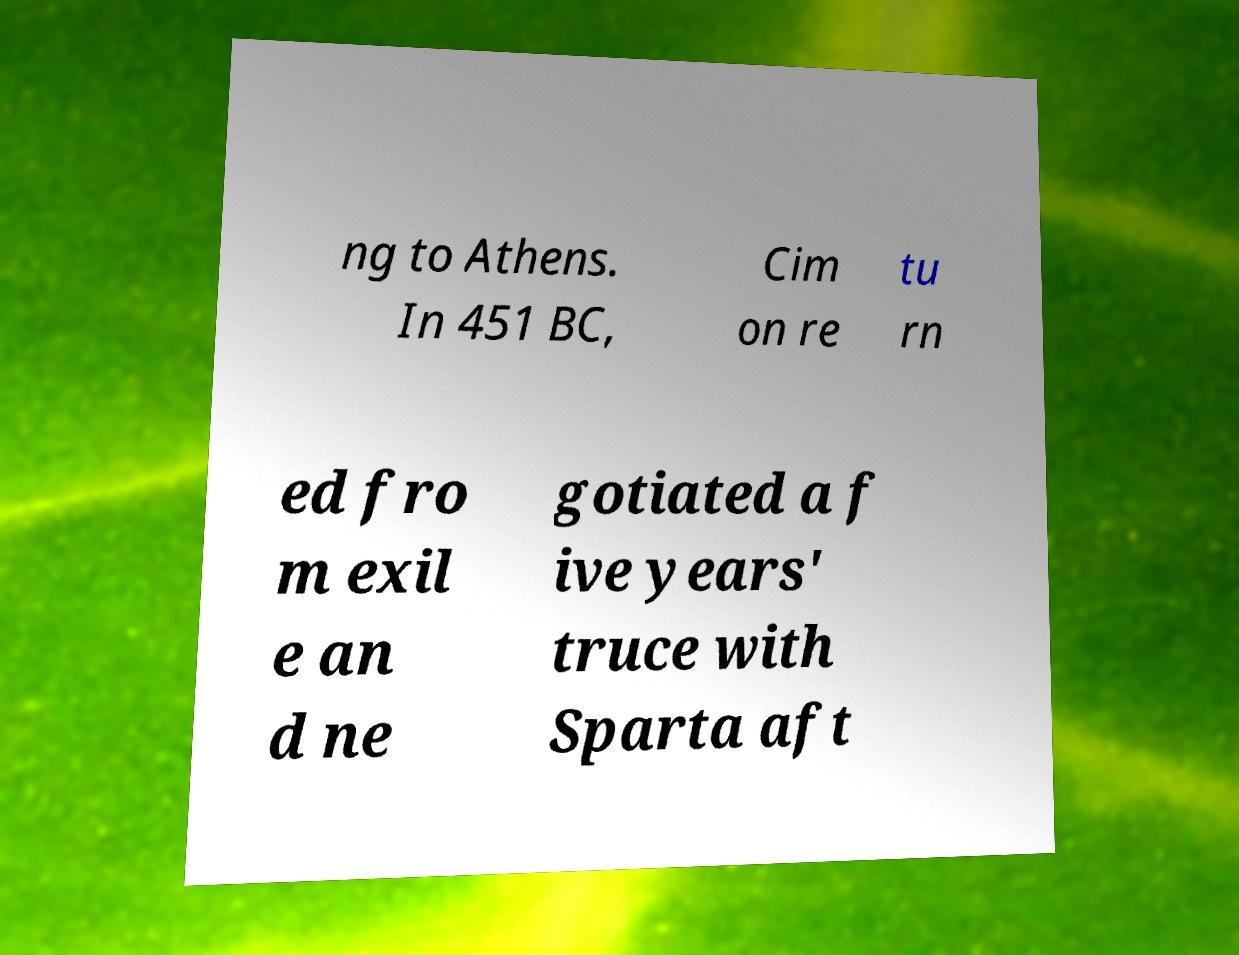Could you extract and type out the text from this image? ng to Athens. In 451 BC, Cim on re tu rn ed fro m exil e an d ne gotiated a f ive years' truce with Sparta aft 